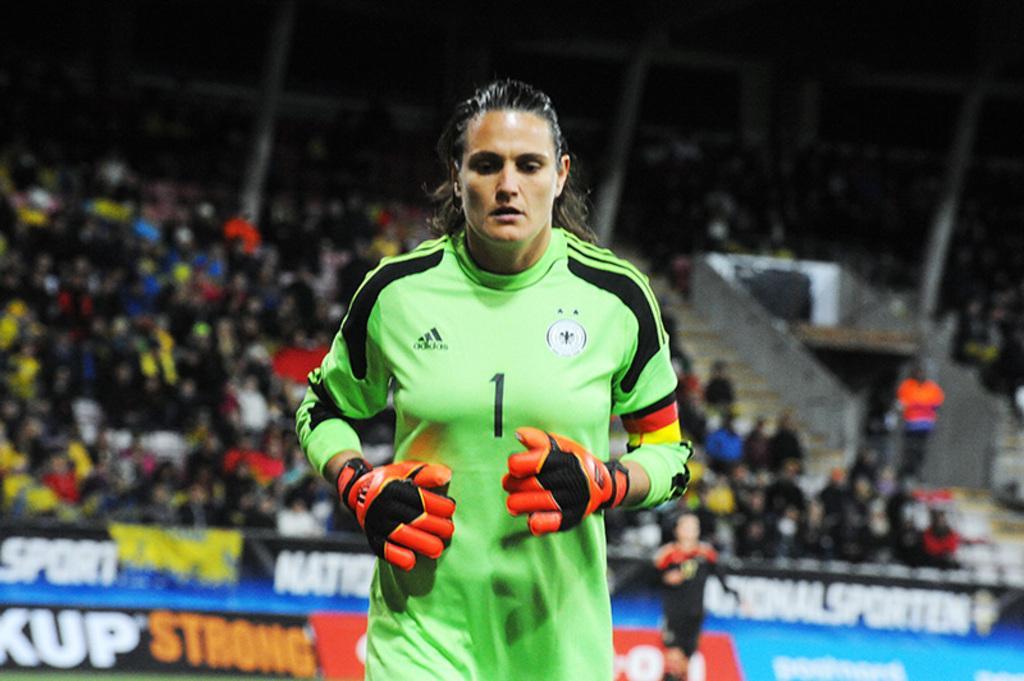In one or two sentences, can you explain what this image depicts? In this picture I can see a woman in front, who is wearing green and black color jersey and I see that she is wearing gloves. In the background I can see the boards, on which there is something written and I see number of people and I can also see that it is blurred in the background and on the top of this picture I see that it is a bit dark. 